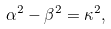Convert formula to latex. <formula><loc_0><loc_0><loc_500><loc_500>\alpha ^ { 2 } - \beta ^ { 2 } = \kappa ^ { 2 } ,</formula> 